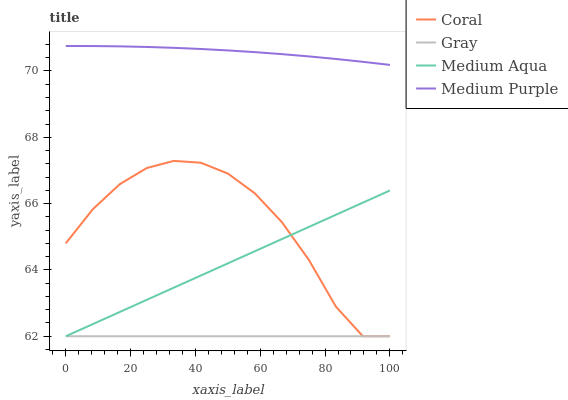Does Coral have the minimum area under the curve?
Answer yes or no. No. Does Coral have the maximum area under the curve?
Answer yes or no. No. Is Coral the smoothest?
Answer yes or no. No. Is Gray the roughest?
Answer yes or no. No. Does Coral have the highest value?
Answer yes or no. No. Is Medium Aqua less than Medium Purple?
Answer yes or no. Yes. Is Medium Purple greater than Coral?
Answer yes or no. Yes. Does Medium Aqua intersect Medium Purple?
Answer yes or no. No. 